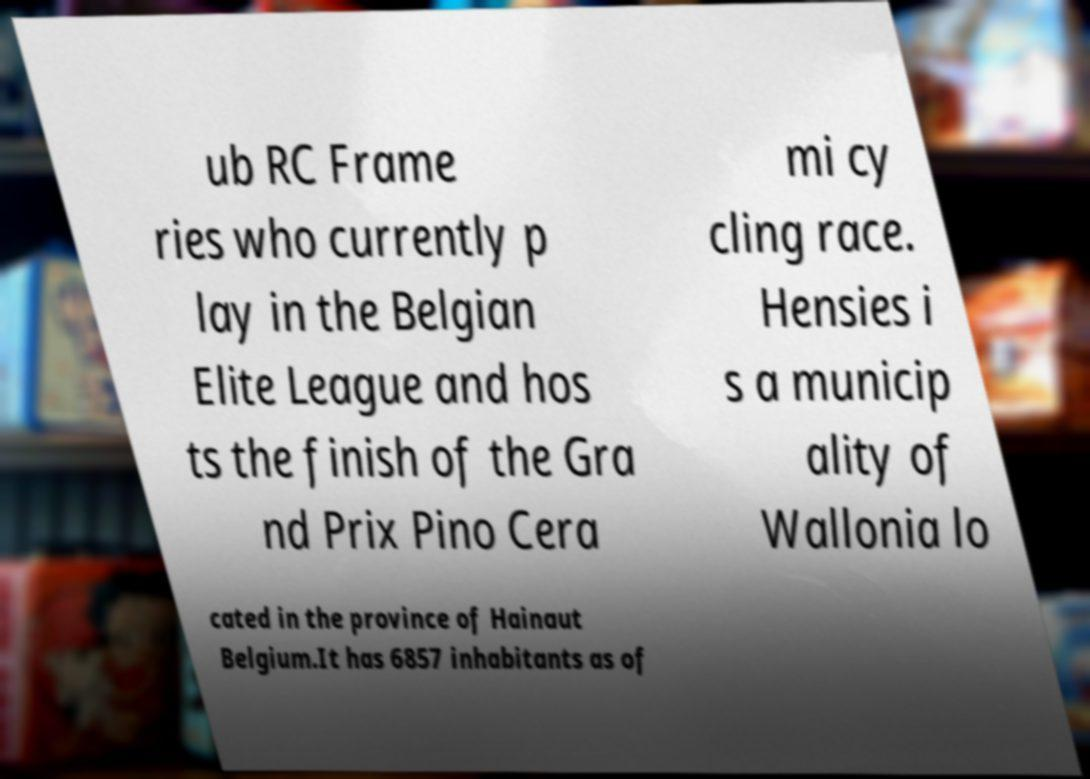I need the written content from this picture converted into text. Can you do that? ub RC Frame ries who currently p lay in the Belgian Elite League and hos ts the finish of the Gra nd Prix Pino Cera mi cy cling race. Hensies i s a municip ality of Wallonia lo cated in the province of Hainaut Belgium.It has 6857 inhabitants as of 